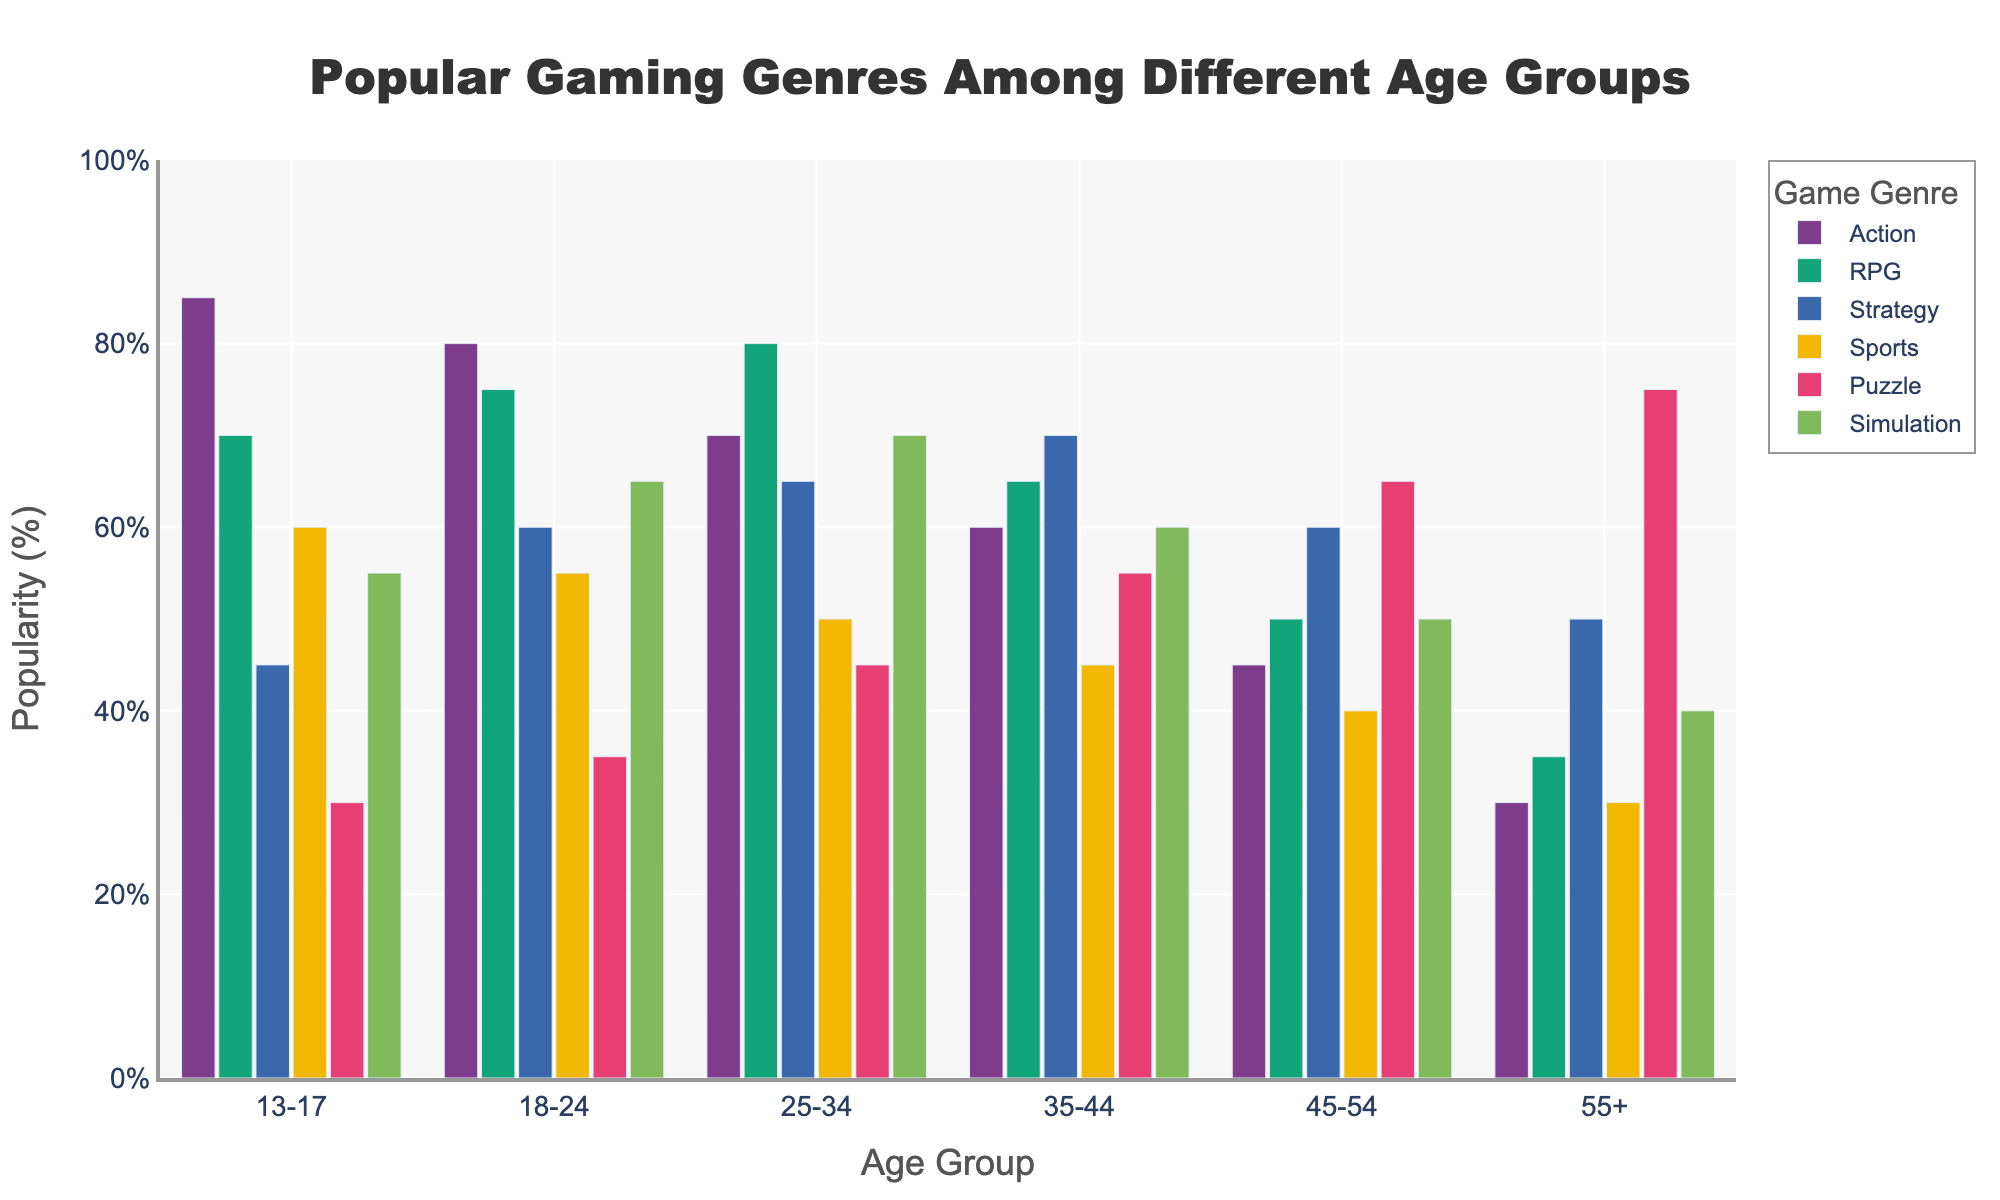Which age group has the highest popularity for RPG games? By examining the length of the bars for RPG games, we see that the 25-34 age group has the longest bar, indicating the highest popularity.
Answer: 25-34 Which two age groups have the same popularity percentage for Sports games? Looking at the bars for Sports games, the 13-17 and 18-24 age groups both have bars reaching 60%.
Answer: 13-17, 18-24 What is the sum of the popularity percentages of Puzzle games for the 35-44 and 45-54 age groups? The popularity of Puzzle games for the 35-44 age group is 55% and for the 45-54 age group is 65%. Summing these gives 55 + 65 = 120%.
Answer: 120% Is the bar for Action games in the 13-17 age group taller than the bar for Action games in the 25-34 age group? Comparing the bars for Action games, the 13-17 age group has a bar reaching 85% while the 25-34 age group has a bar at 70%, so yes, the 13-17 bar is taller.
Answer: Yes Across all age groups, is the popularity of Simulation games greater than or equal to the popularity of Puzzle games? Comparing each pair of bars for Simulation and Puzzle games across all age groups, Simulation games generally have higher or equal popularity: 55 ≥ 30, 65 ≥ 35, 70 > 45, 60 > 55, 50 < 65, 40 < 75. For some age groups, Simulation is lower, so not always greater or equal.
Answer: No What is the average popularity of Strategy games for the age groups 18-24 and 25-34? The popularity of Strategy games is 60% for 18-24 and 65% for 25-34. Average is (60 + 65) / 2 = 62.5%.
Answer: 62.5% Is the popularity of RPG games for the 45-54 age group more than that for Simulation games in the same age group? The RPG popularity is 50% and Simulation is 50% for the 45-54 age group. Since both are equal, RPG is not more than Simulation.
Answer: No Which genre has the least popularity among the 55+ age group? The bars for the 55+ age group show that Action tops at 30%, RPG at 35%, Strategy and Simulation both at 50%, Sports at 30%, and Puzzle at 75%. Action and Sports both share the least popularity with 30%.
Answer: Action, Sports What's the difference in popularity for Simulation games between the 13-17 and 35-44 age groups? Simulation games are 55% popular in the 13-17 age group and 60% in the 35-44 age group. The difference is 60 - 55 = 5%.
Answer: 5% 